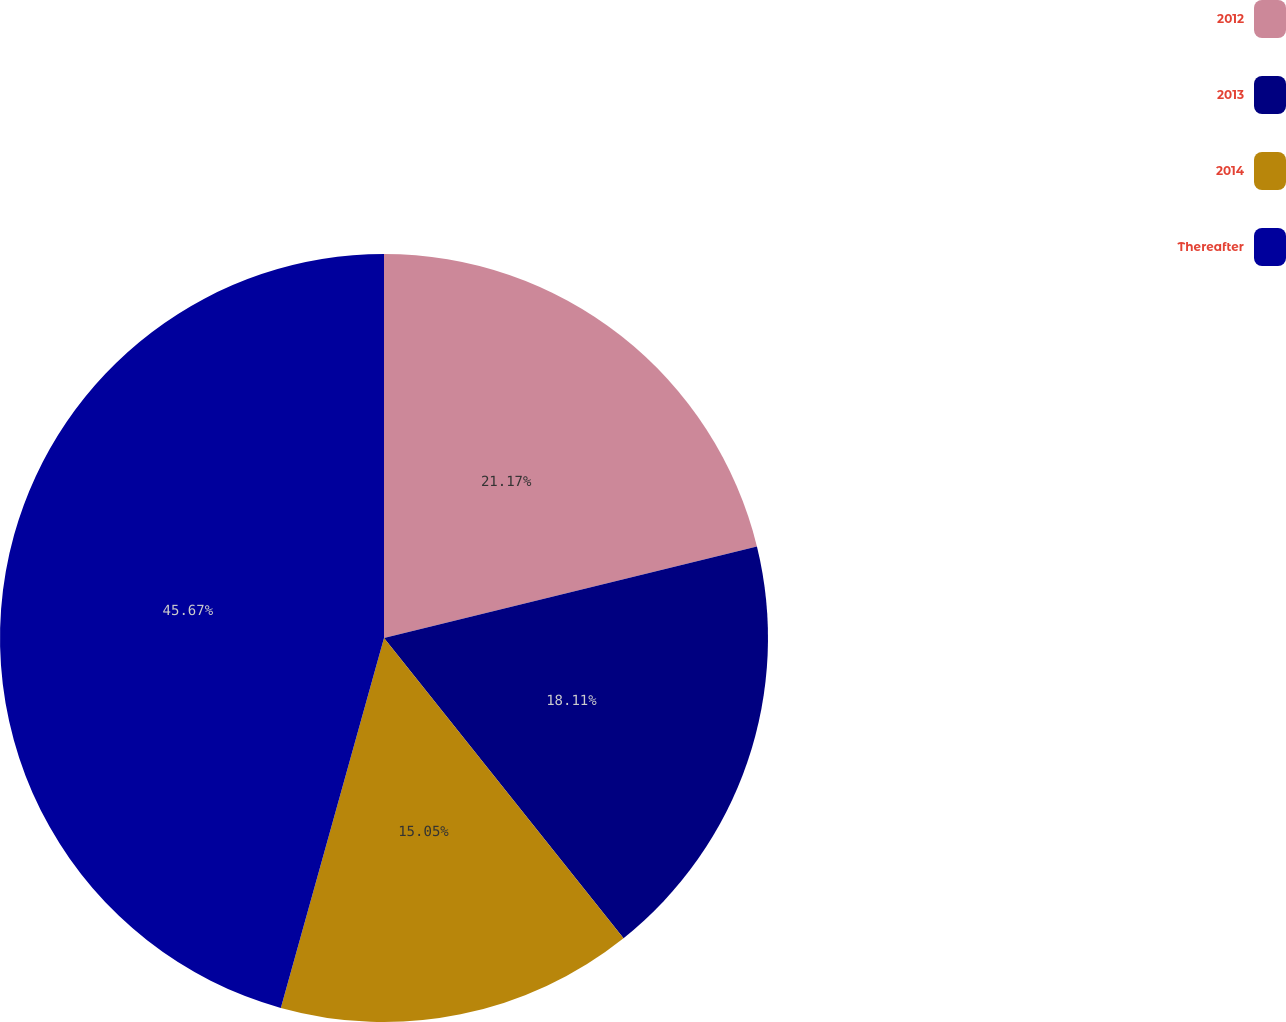Convert chart. <chart><loc_0><loc_0><loc_500><loc_500><pie_chart><fcel>2012<fcel>2013<fcel>2014<fcel>Thereafter<nl><fcel>21.17%<fcel>18.11%<fcel>15.05%<fcel>45.67%<nl></chart> 